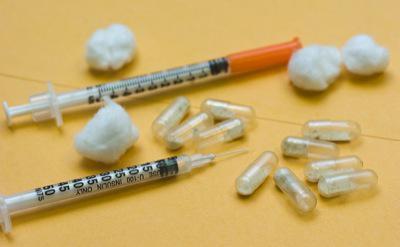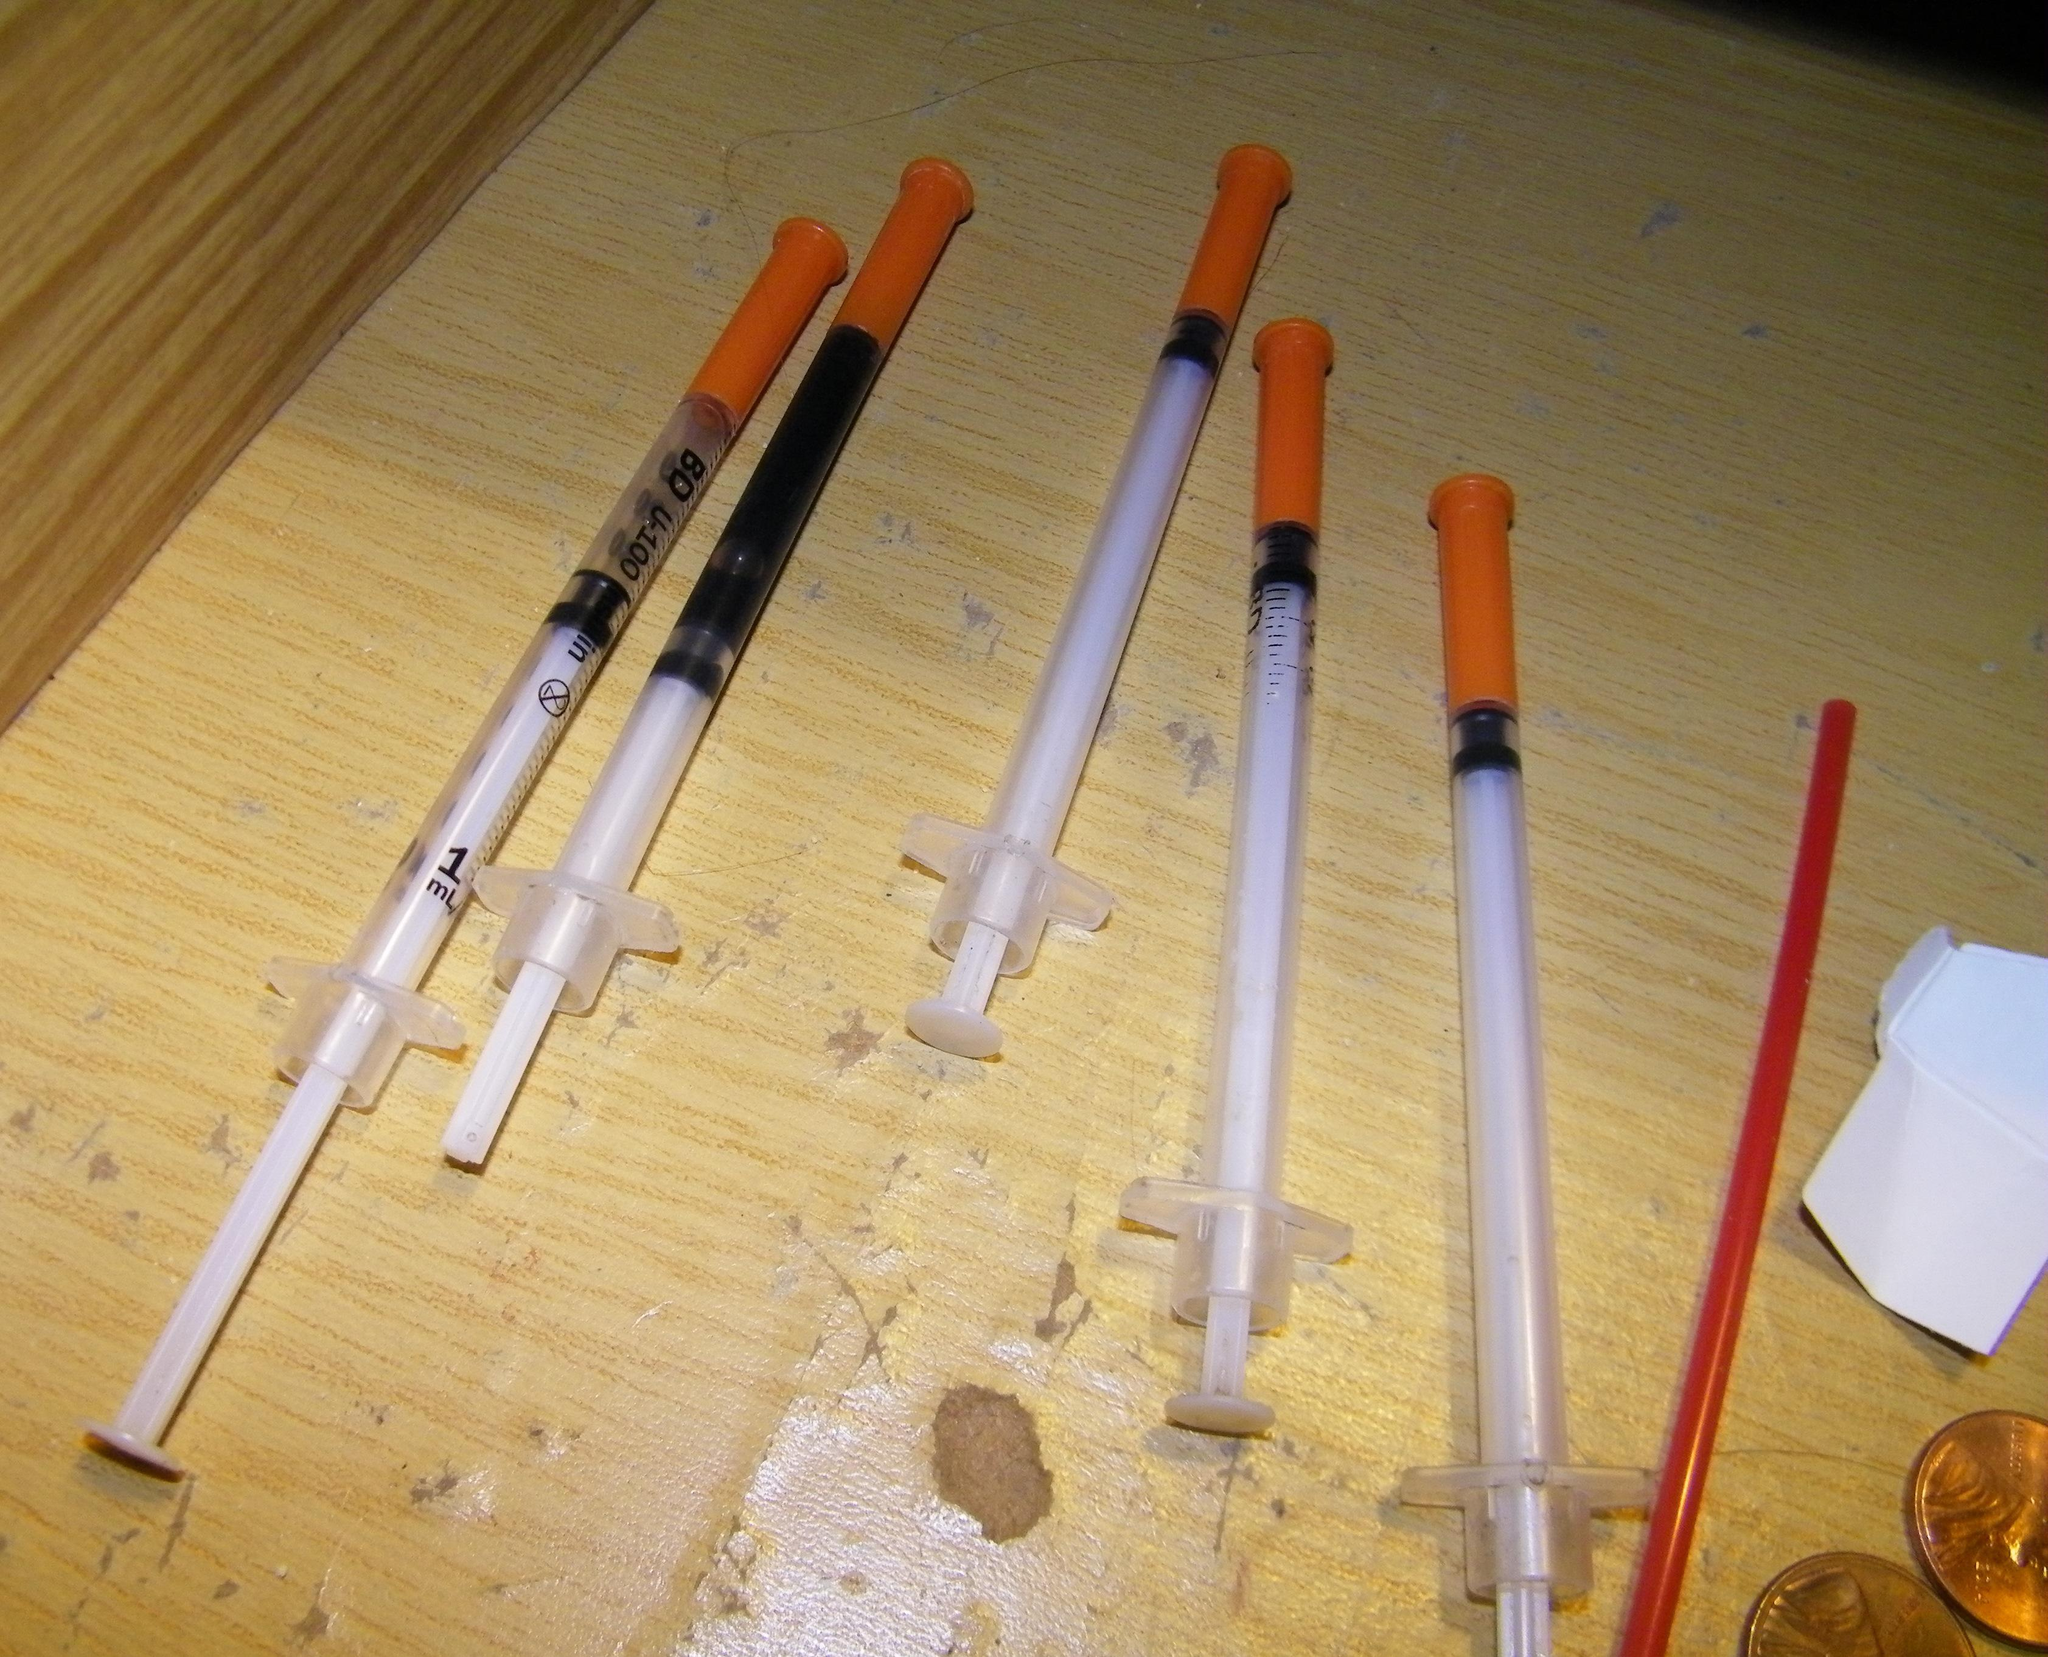The first image is the image on the left, the second image is the image on the right. Analyze the images presented: Is the assertion "The image on the left contains exactly one syringe with an orange cap." valid? Answer yes or no. Yes. The first image is the image on the left, the second image is the image on the right. Considering the images on both sides, is "An image shows only one syringe, and its needle is exposed." valid? Answer yes or no. No. 